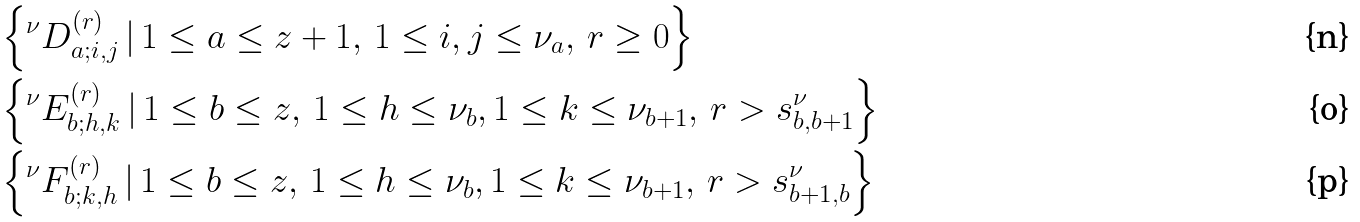Convert formula to latex. <formula><loc_0><loc_0><loc_500><loc_500>& \left \{ ^ { \nu } D _ { a ; i , j } ^ { ( r ) } \, | \, { 1 \leq a \leq z + 1 , \, 1 \leq i , j \leq \nu _ { a } , \, r \geq 0 } \right \} \\ & \left \{ ^ { \nu } E _ { b ; h , k } ^ { ( r ) } \, | \, { 1 \leq b \leq z , \, 1 \leq h \leq \nu _ { b } , 1 \leq k \leq \nu _ { b + 1 } , \, r > s _ { b , b + 1 } ^ { \nu } } \right \} \\ & \left \{ ^ { \nu } F _ { b ; k , h } ^ { ( r ) } \, | \, { 1 \leq b \leq z , \, 1 \leq h \leq \nu _ { b } , 1 \leq k \leq \nu _ { b + 1 } , \, r > s _ { b + 1 , b } ^ { \nu } } \right \}</formula> 